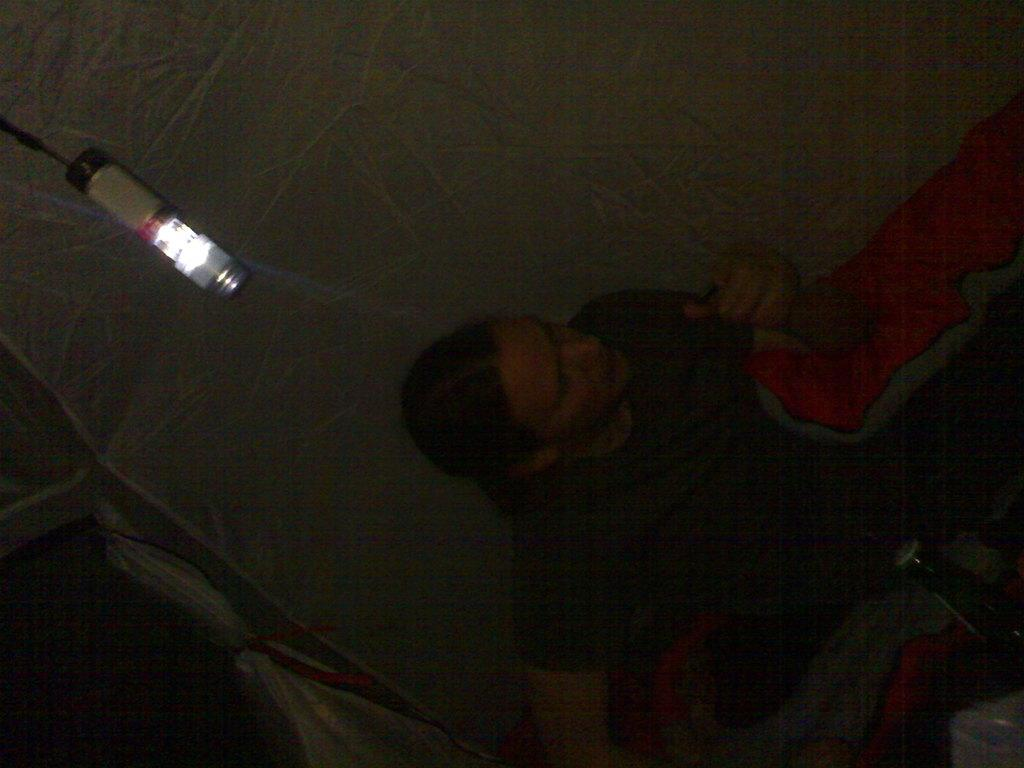Who or what is present in the image? There is a person in the image. What is the person wearing? The person is wearing clothes. What else can be seen in the image besides the person? There is a bottle in the image. Can you describe the lighting conditions in the image? There is light visible in the image. What type of circle can be seen on the person's shirt in the image? There is no circle mentioned or visible on the person's shirt in the image. How does the snail contribute to the image? There is no snail present in the image. 